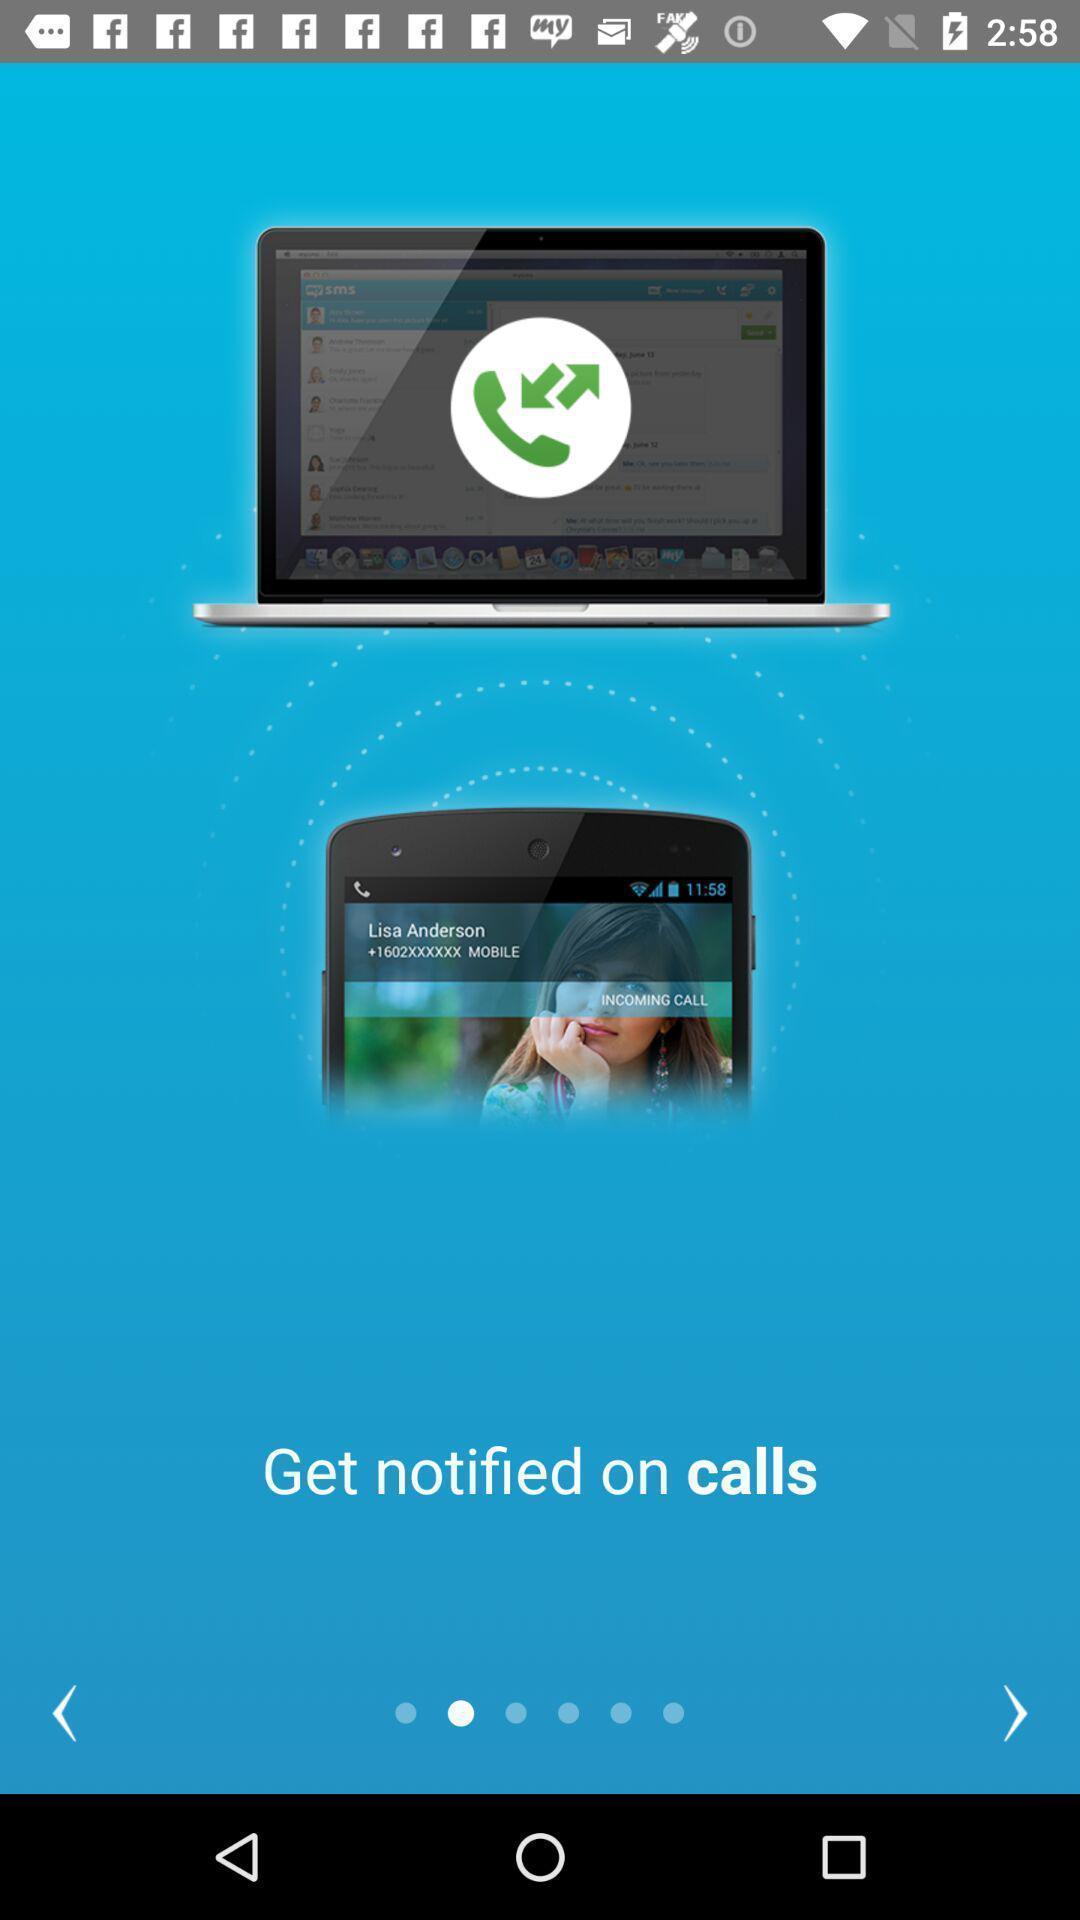Describe the content in this image. Welcome page for an application. 